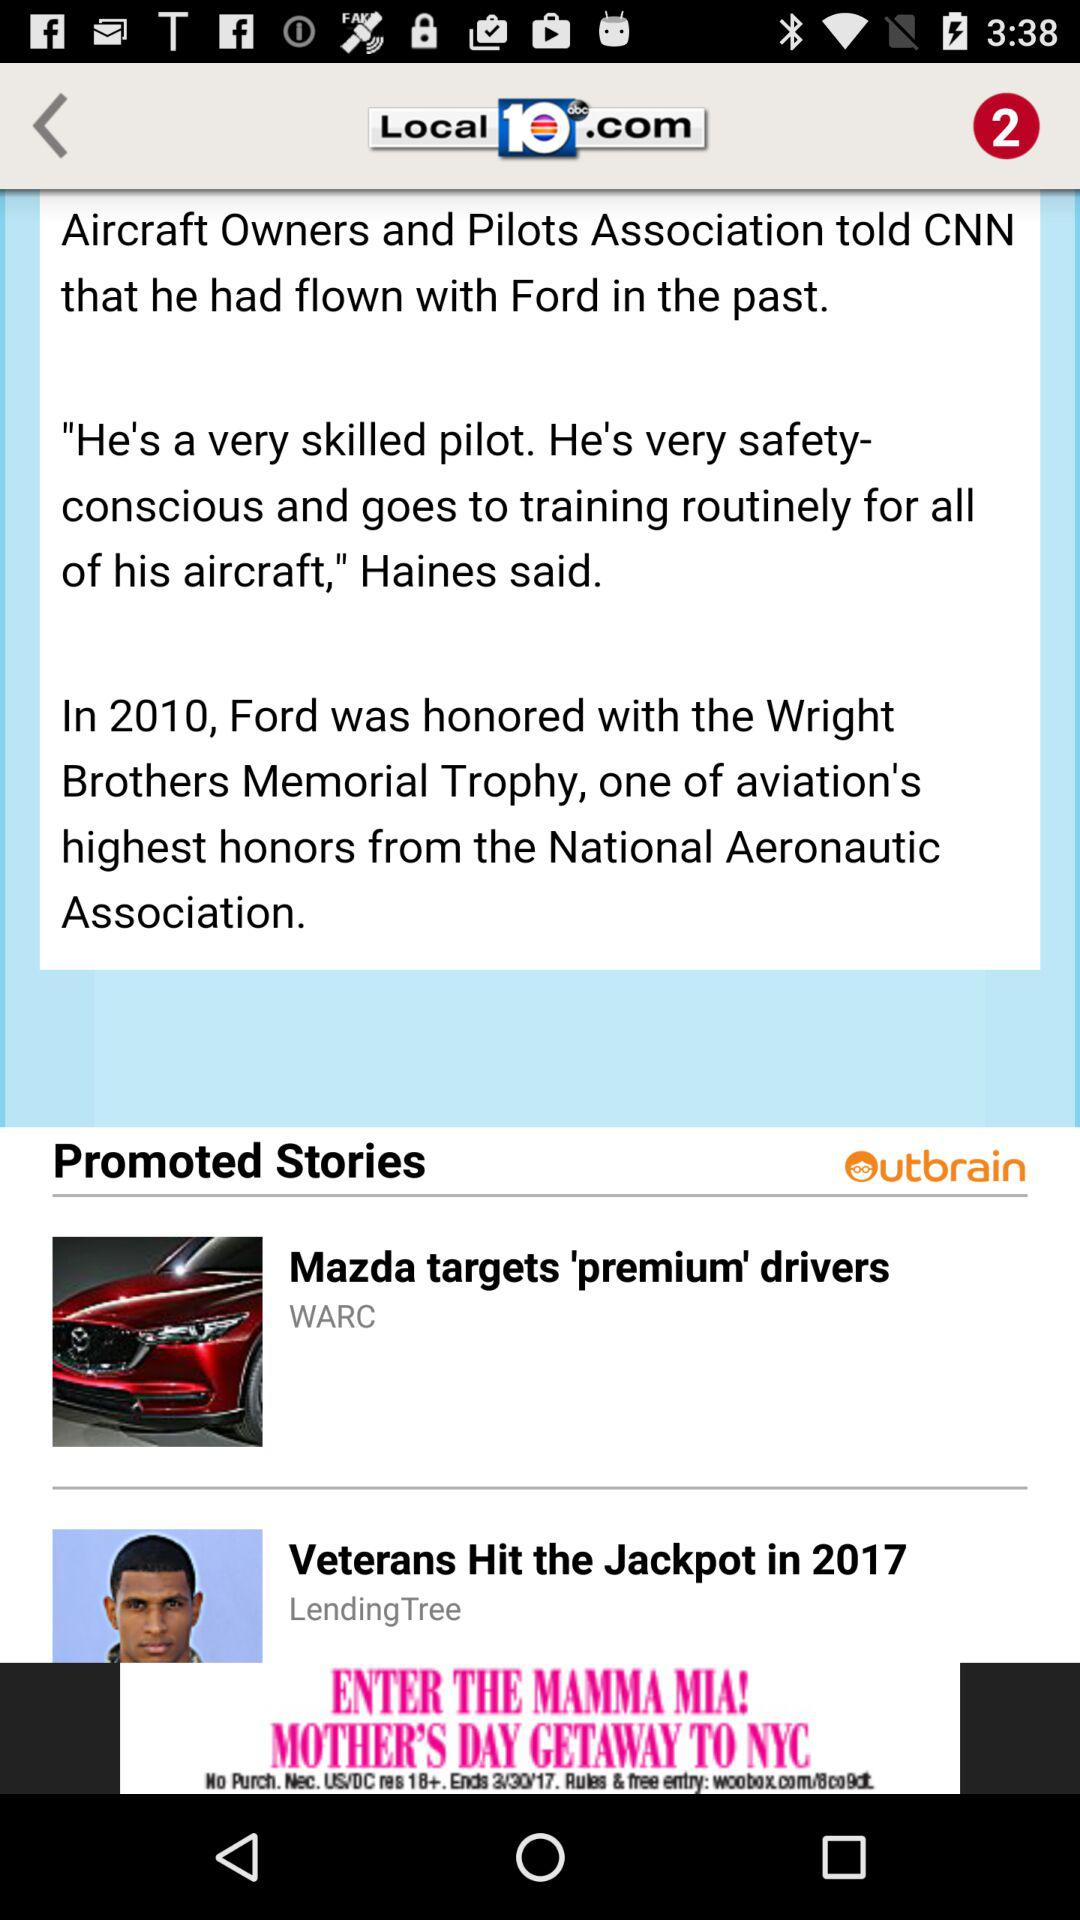In which year was Ford honored with the "Wright Brothers Memorial Trophy"? Ford was honored with the "Wright Brothers Memorial Trophy" in 2010. 